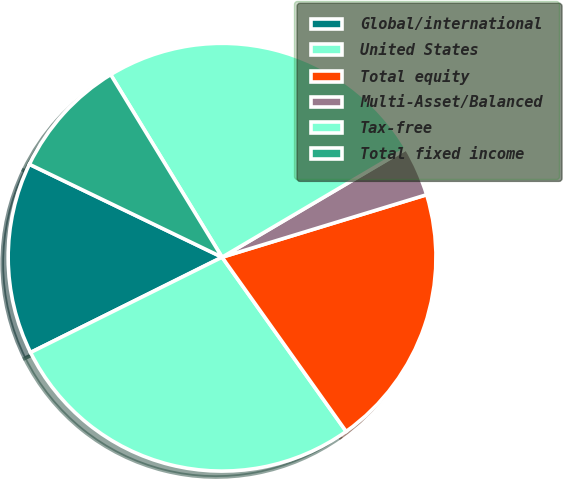Convert chart to OTSL. <chart><loc_0><loc_0><loc_500><loc_500><pie_chart><fcel>Global/international<fcel>United States<fcel>Total equity<fcel>Multi-Asset/Balanced<fcel>Tax-free<fcel>Total fixed income<nl><fcel>14.5%<fcel>27.5%<fcel>19.87%<fcel>3.76%<fcel>25.24%<fcel>9.13%<nl></chart> 